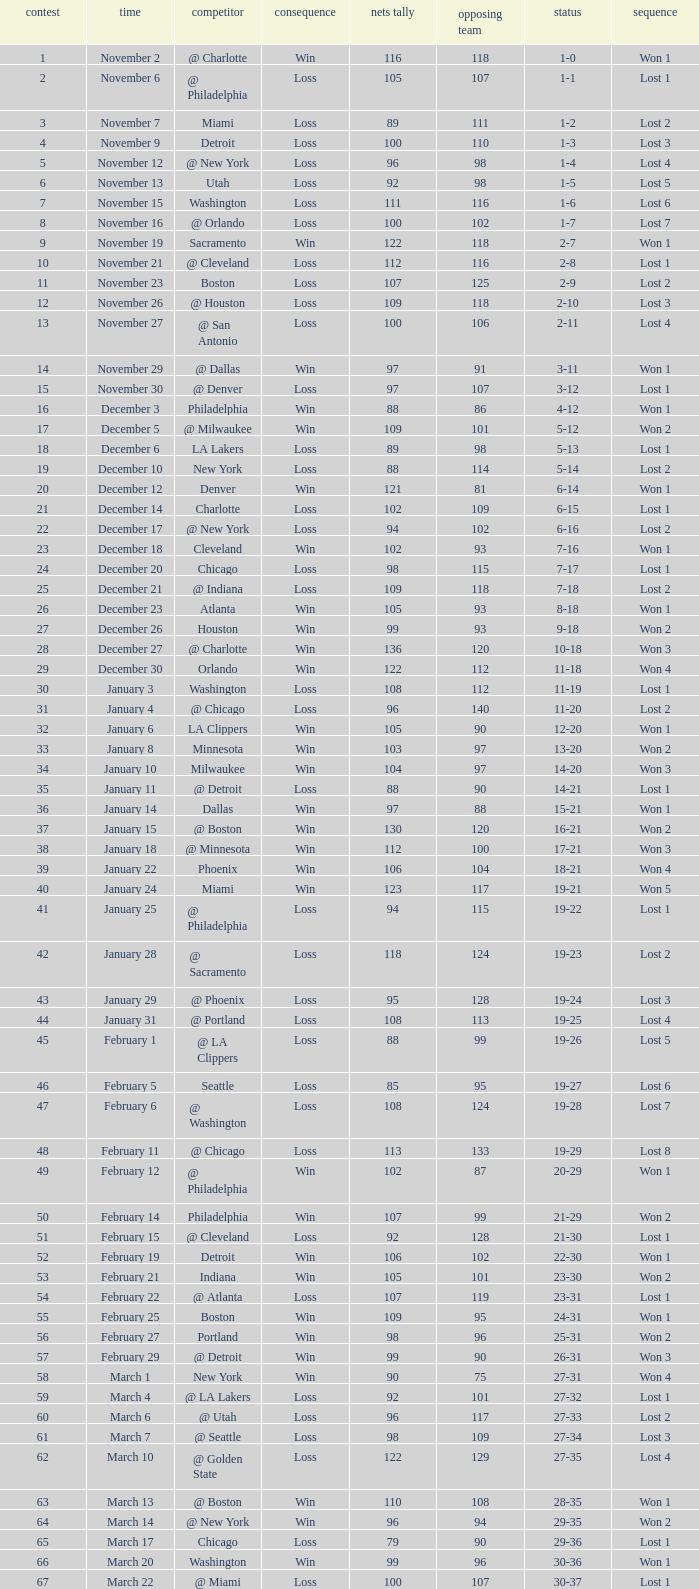How many opponents were there in a game higher than 20 on January 28? 124.0. 